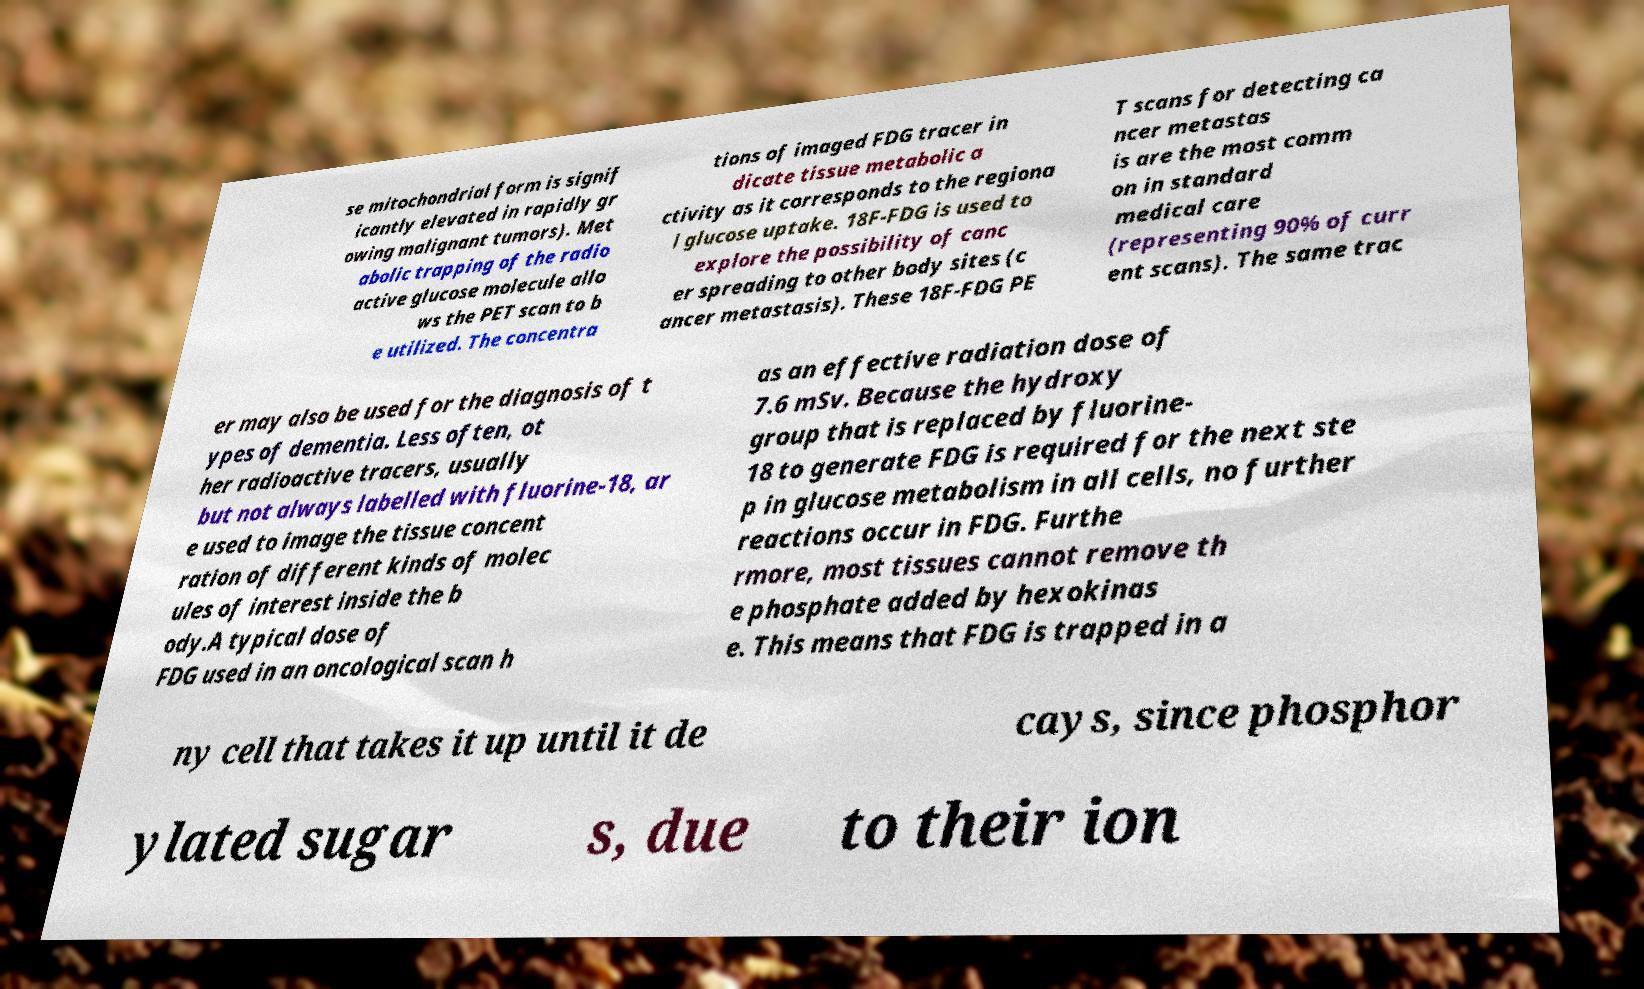For documentation purposes, I need the text within this image transcribed. Could you provide that? se mitochondrial form is signif icantly elevated in rapidly gr owing malignant tumors). Met abolic trapping of the radio active glucose molecule allo ws the PET scan to b e utilized. The concentra tions of imaged FDG tracer in dicate tissue metabolic a ctivity as it corresponds to the regiona l glucose uptake. 18F-FDG is used to explore the possibility of canc er spreading to other body sites (c ancer metastasis). These 18F-FDG PE T scans for detecting ca ncer metastas is are the most comm on in standard medical care (representing 90% of curr ent scans). The same trac er may also be used for the diagnosis of t ypes of dementia. Less often, ot her radioactive tracers, usually but not always labelled with fluorine-18, ar e used to image the tissue concent ration of different kinds of molec ules of interest inside the b ody.A typical dose of FDG used in an oncological scan h as an effective radiation dose of 7.6 mSv. Because the hydroxy group that is replaced by fluorine- 18 to generate FDG is required for the next ste p in glucose metabolism in all cells, no further reactions occur in FDG. Furthe rmore, most tissues cannot remove th e phosphate added by hexokinas e. This means that FDG is trapped in a ny cell that takes it up until it de cays, since phosphor ylated sugar s, due to their ion 